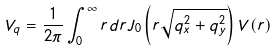<formula> <loc_0><loc_0><loc_500><loc_500>V _ { q } = \frac { 1 } { 2 \pi } \int _ { 0 } ^ { \infty } r d r J _ { 0 } \left ( r \sqrt { q _ { x } ^ { 2 } + q _ { y } ^ { 2 } } \right ) V ( r )</formula> 